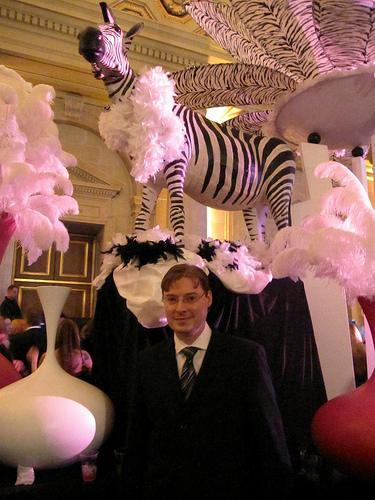Which object in the image can be considered an unusual combination, and what does it consist of? An unusual combination is the zebra with white feathers, which consists of a zebra statue covered in white feathery plumes. Provide a brief description of the most prominent object in the image. A large zebra statue with white and black stripes is dominating the scene. Can you identify a woman who wears a specific type of clothing in the image? There is a woman with thin dress straps in the scene. Mention any two striped objects in the image and the colors they exhibit. Two striped objects are the large zebra statue, which has black and white stripes, and the tie on the man, which shows black, white, and grey stripes. What kind of event is possibly taking place in the image, and who is attending it? It could be a social event, with people dressed in suits and dresses in the background. In a formal tone, describe the attire and any prominent accessories of the man located centrally in the image. A gentleman is adorned in an elegant black three-piece suit, complete with white shirt, black, white, and grey striped tie, and spectacles. Which object is positioned closest to the top-left corner of the image? Mention its color scheme as well. A large zebra statue with black and white stripes is positioned closest to the top-left corner. Name two objects that are related to clothing items present on the man in the suit in the image. A pair of spectacles and a white shirt on the man are related to clothing items. What is positioned above the door in the image, and what shape is it? A triangular structure is situated above the door. What is the zebra in the image interacting with, and how is it positioned? The zebra statue appears to have white feathers on it and is positioned at the upper part of the image. 